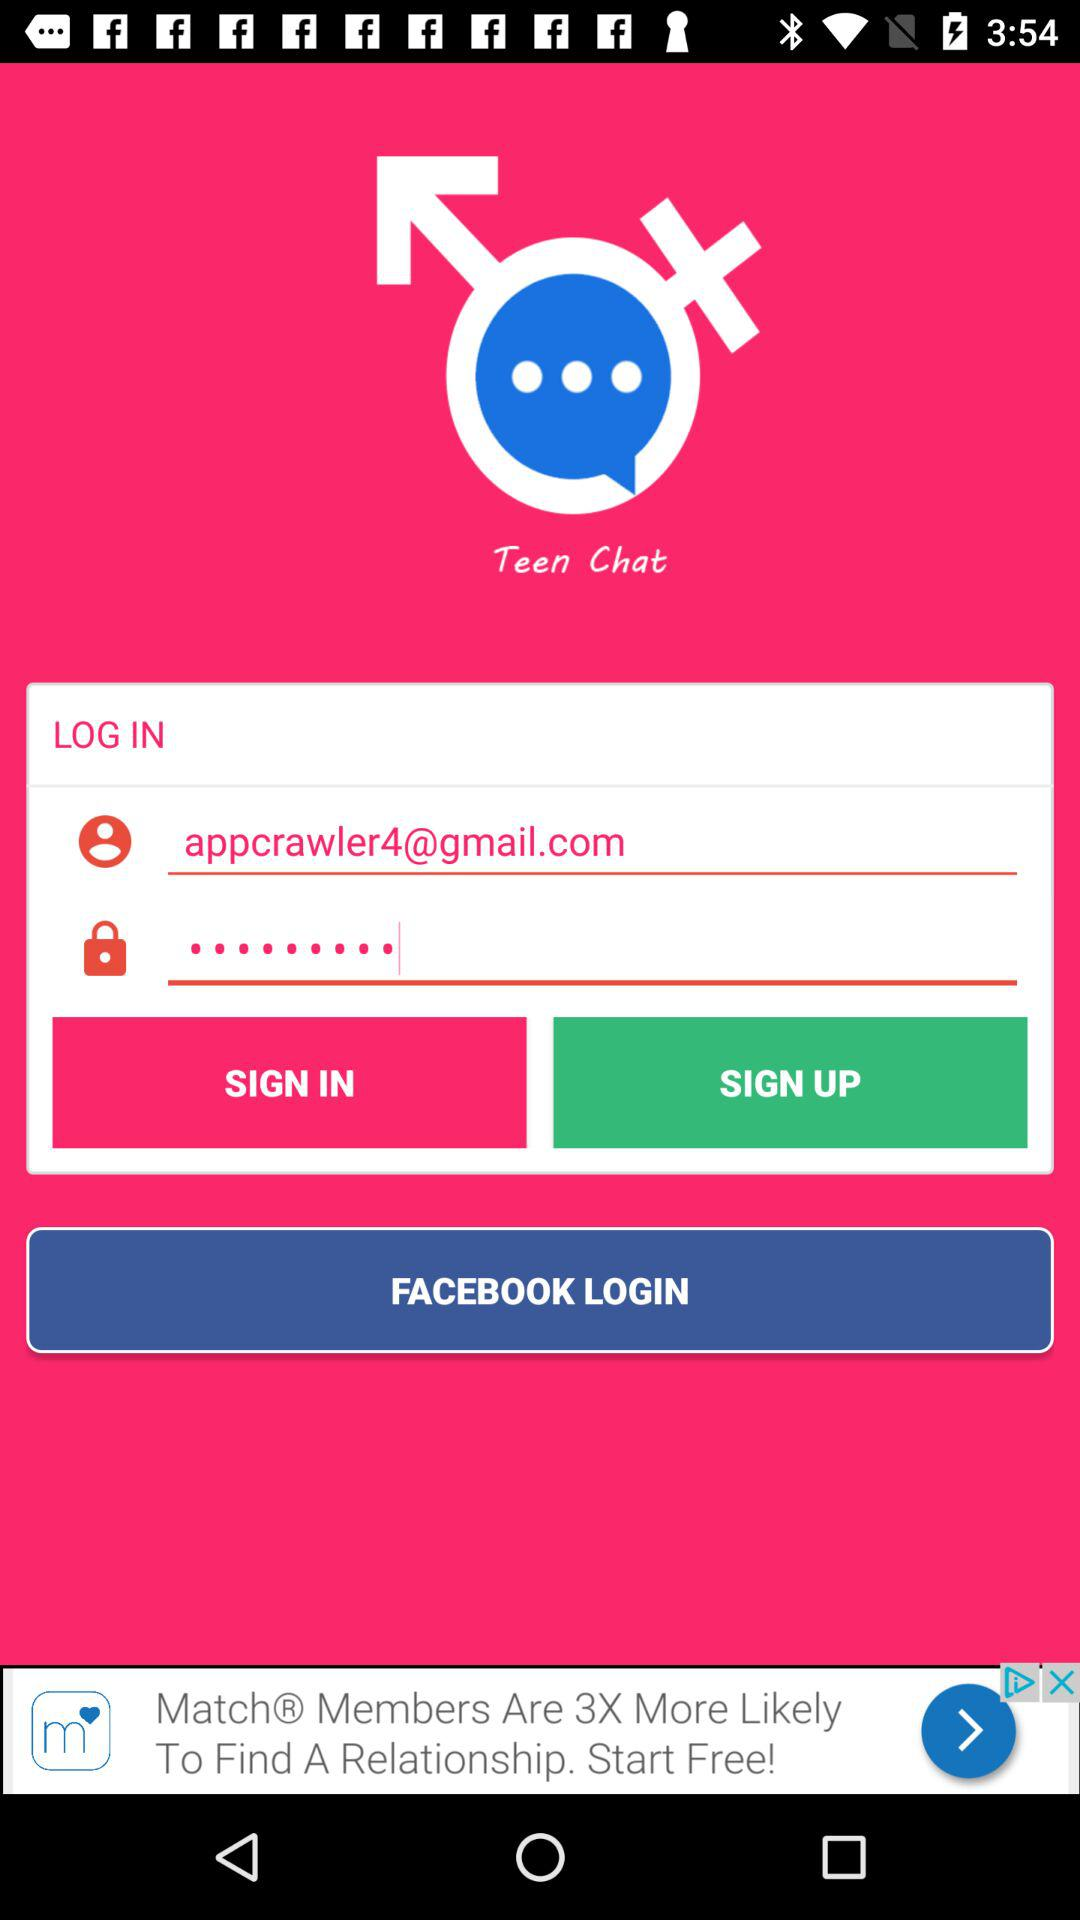What is the email address? The email address is appcrawler4@gmail.com. 